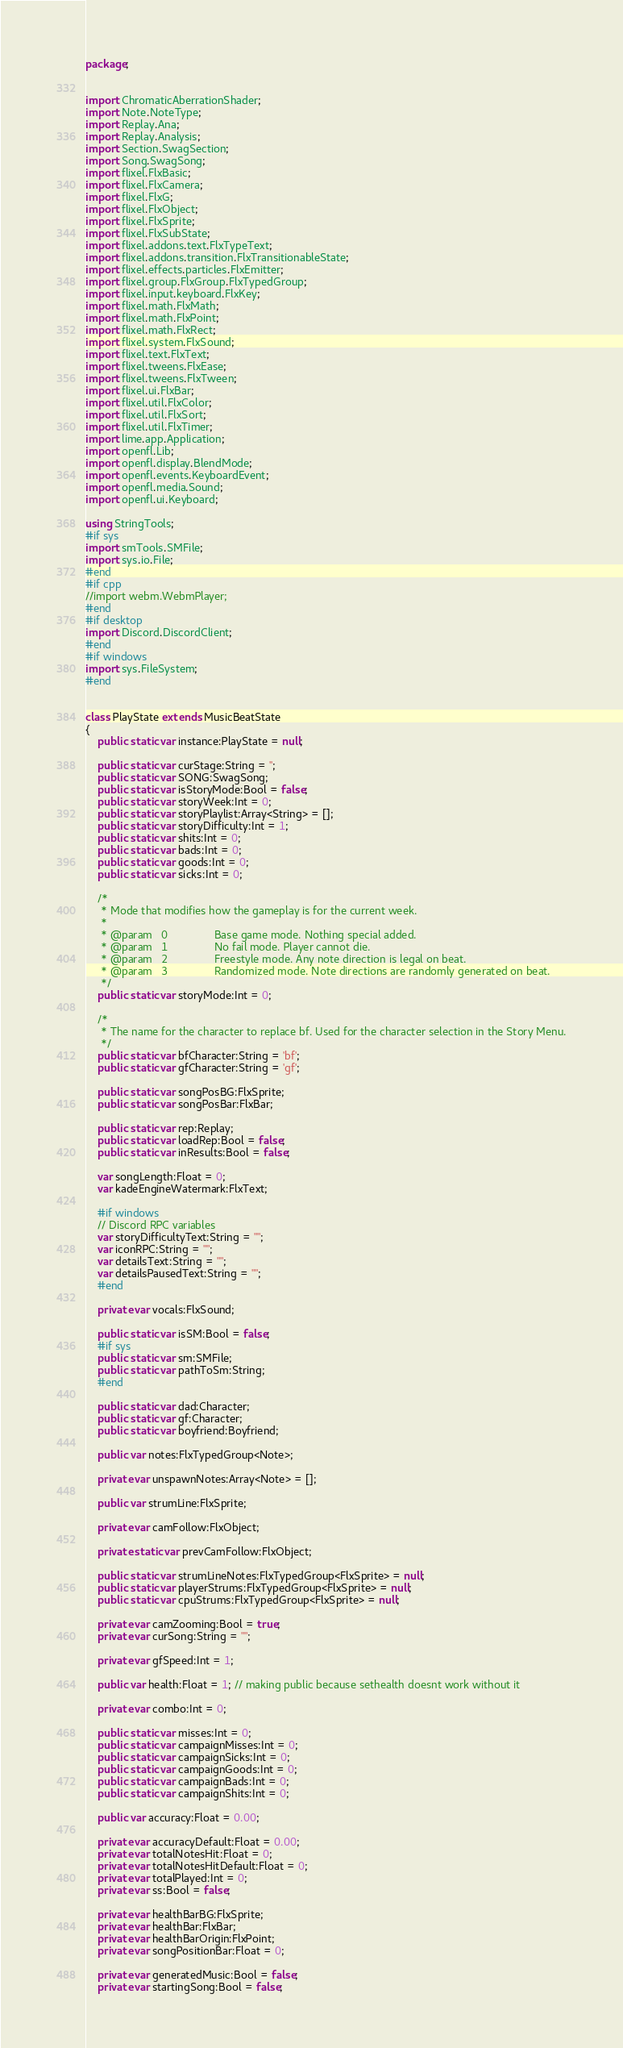Convert code to text. <code><loc_0><loc_0><loc_500><loc_500><_Haxe_>package;


import ChromaticAberrationShader;
import Note.NoteType;
import Replay.Ana;
import Replay.Analysis;
import Section.SwagSection;
import Song.SwagSong;
import flixel.FlxBasic;
import flixel.FlxCamera;
import flixel.FlxG;
import flixel.FlxObject;
import flixel.FlxSprite;
import flixel.FlxSubState;
import flixel.addons.text.FlxTypeText;
import flixel.addons.transition.FlxTransitionableState;
import flixel.effects.particles.FlxEmitter;
import flixel.group.FlxGroup.FlxTypedGroup;
import flixel.input.keyboard.FlxKey;
import flixel.math.FlxMath;
import flixel.math.FlxPoint;
import flixel.math.FlxRect;
import flixel.system.FlxSound;
import flixel.text.FlxText;
import flixel.tweens.FlxEase;
import flixel.tweens.FlxTween;
import flixel.ui.FlxBar;
import flixel.util.FlxColor;
import flixel.util.FlxSort;
import flixel.util.FlxTimer;
import lime.app.Application;
import openfl.Lib;
import openfl.display.BlendMode;
import openfl.events.KeyboardEvent;
import openfl.media.Sound;
import openfl.ui.Keyboard;

using StringTools;
#if sys
import smTools.SMFile;
import sys.io.File;
#end
#if cpp
//import webm.WebmPlayer;
#end
#if desktop
import Discord.DiscordClient;
#end
#if windows
import sys.FileSystem;
#end


class PlayState extends MusicBeatState
{
	public static var instance:PlayState = null;

	public static var curStage:String = '';
	public static var SONG:SwagSong;
	public static var isStoryMode:Bool = false;
	public static var storyWeek:Int = 0;
	public static var storyPlaylist:Array<String> = [];
	public static var storyDifficulty:Int = 1;
	public static var shits:Int = 0;
	public static var bads:Int = 0;
	public static var goods:Int = 0;
	public static var sicks:Int = 0;

	/*
	 * Mode that modifies how the gameplay is for the current week.
	 *
	 * @param	0				Base game mode. Nothing special added.
	 * @param	1				No fail mode. Player cannot die.
	 * @param	2				Freestyle mode. Any note direction is legal on beat.
	 * @param	3				Randomized mode. Note directions are randomly generated on beat.
	 */
	public static var storyMode:Int = 0;

	/*
	 * The name for the character to replace bf. Used for the character selection in the Story Menu.
	 */
	public static var bfCharacter:String = 'bf';
	public static var gfCharacter:String = 'gf';

	public static var songPosBG:FlxSprite;
	public static var songPosBar:FlxBar;

	public static var rep:Replay;
	public static var loadRep:Bool = false;
	public static var inResults:Bool = false;

	var songLength:Float = 0;
	var kadeEngineWatermark:FlxText;

	#if windows
	// Discord RPC variables
	var storyDifficultyText:String = "";
	var iconRPC:String = "";
	var detailsText:String = "";
	var detailsPausedText:String = "";
	#end

	private var vocals:FlxSound;

	public static var isSM:Bool = false;
	#if sys
	public static var sm:SMFile;
	public static var pathToSm:String;
	#end

	public static var dad:Character;
	public static var gf:Character;
	public static var boyfriend:Boyfriend;

	public var notes:FlxTypedGroup<Note>;

	private var unspawnNotes:Array<Note> = [];

	public var strumLine:FlxSprite;

	private var camFollow:FlxObject;

	private static var prevCamFollow:FlxObject;

	public static var strumLineNotes:FlxTypedGroup<FlxSprite> = null;
	public static var playerStrums:FlxTypedGroup<FlxSprite> = null;
	public static var cpuStrums:FlxTypedGroup<FlxSprite> = null;

	private var camZooming:Bool = true;
	private var curSong:String = "";

	private var gfSpeed:Int = 1;

	public var health:Float = 1; // making public because sethealth doesnt work without it

	private var combo:Int = 0;

	public static var misses:Int = 0;
	public static var campaignMisses:Int = 0;
	public static var campaignSicks:Int = 0;
	public static var campaignGoods:Int = 0;
	public static var campaignBads:Int = 0;
	public static var campaignShits:Int = 0;

	public var accuracy:Float = 0.00;

	private var accuracyDefault:Float = 0.00;
	private var totalNotesHit:Float = 0;
	private var totalNotesHitDefault:Float = 0;
	private var totalPlayed:Int = 0;
	private var ss:Bool = false;

	private var healthBarBG:FlxSprite;
	private var healthBar:FlxBar;
	private var healthBarOrigin:FlxPoint;
	private var songPositionBar:Float = 0;

	private var generatedMusic:Bool = false;
	private var startingSong:Bool = false;
</code> 